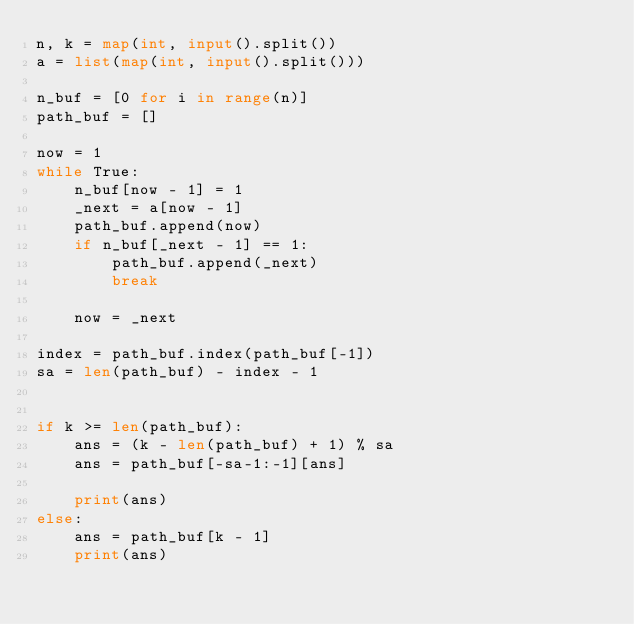<code> <loc_0><loc_0><loc_500><loc_500><_Python_>n, k = map(int, input().split())
a = list(map(int, input().split()))

n_buf = [0 for i in range(n)]
path_buf = []

now = 1
while True:
    n_buf[now - 1] = 1
    _next = a[now - 1]
    path_buf.append(now)
    if n_buf[_next - 1] == 1:
        path_buf.append(_next)
        break

    now = _next

index = path_buf.index(path_buf[-1])
sa = len(path_buf) - index - 1


if k >= len(path_buf):
    ans = (k - len(path_buf) + 1) % sa
    ans = path_buf[-sa-1:-1][ans]

    print(ans)
else:
    ans = path_buf[k - 1]
    print(ans)</code> 